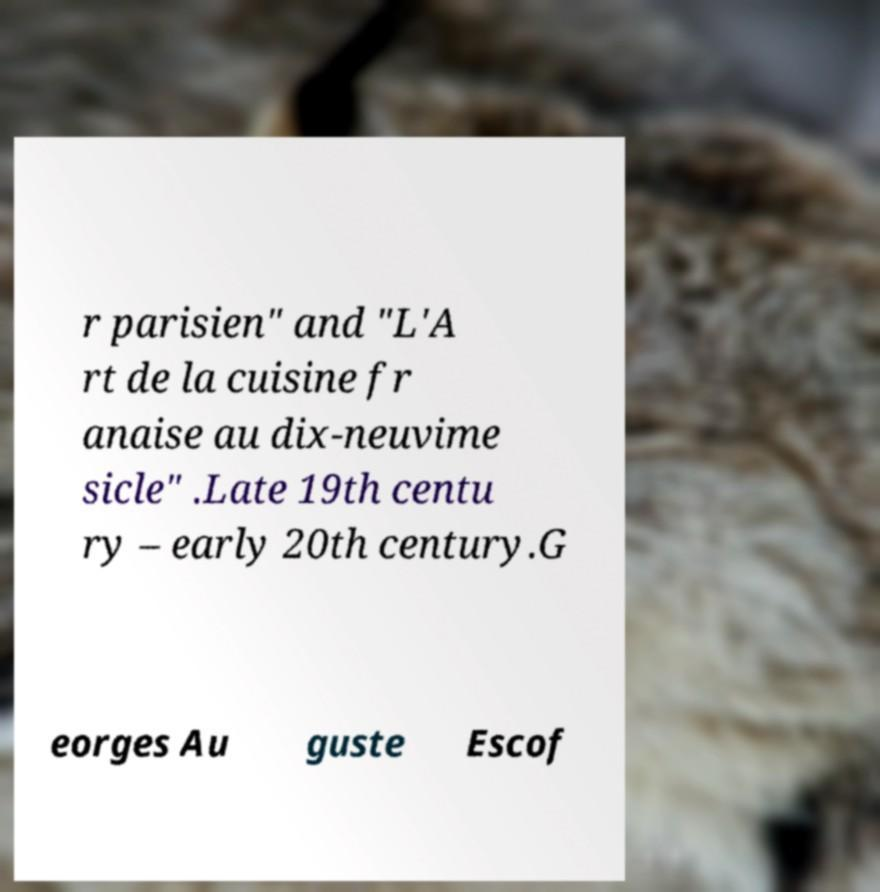Can you read and provide the text displayed in the image?This photo seems to have some interesting text. Can you extract and type it out for me? r parisien" and "L'A rt de la cuisine fr anaise au dix-neuvime sicle" .Late 19th centu ry – early 20th century.G eorges Au guste Escof 